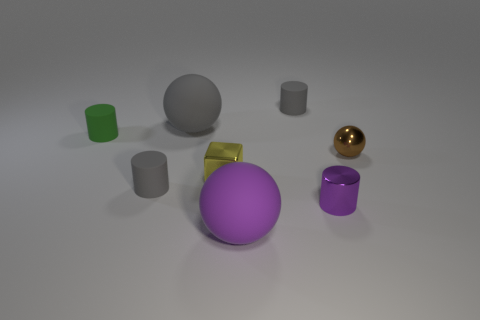There is a small metal object in front of the small gray cylinder on the left side of the metal block; what color is it?
Offer a very short reply. Purple. Are there an equal number of tiny gray matte things left of the big purple ball and big purple matte things?
Offer a terse response. Yes. Are there any purple rubber balls of the same size as the brown sphere?
Make the answer very short. No. Do the green object and the ball on the right side of the small purple shiny object have the same size?
Provide a short and direct response. Yes. Is the number of purple metallic cylinders that are in front of the small purple object the same as the number of metal balls in front of the yellow object?
Make the answer very short. Yes. The thing that is the same color as the small metal cylinder is what shape?
Provide a short and direct response. Sphere. There is a sphere in front of the small purple shiny cylinder; what material is it?
Provide a succinct answer. Rubber. Is the size of the yellow metal cube the same as the metallic ball?
Keep it short and to the point. Yes. Is the number of green matte cylinders on the right side of the green matte cylinder greater than the number of large purple matte things?
Provide a short and direct response. No. What size is the purple ball that is made of the same material as the big gray sphere?
Provide a short and direct response. Large. 